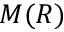Convert formula to latex. <formula><loc_0><loc_0><loc_500><loc_500>M ( R )</formula> 